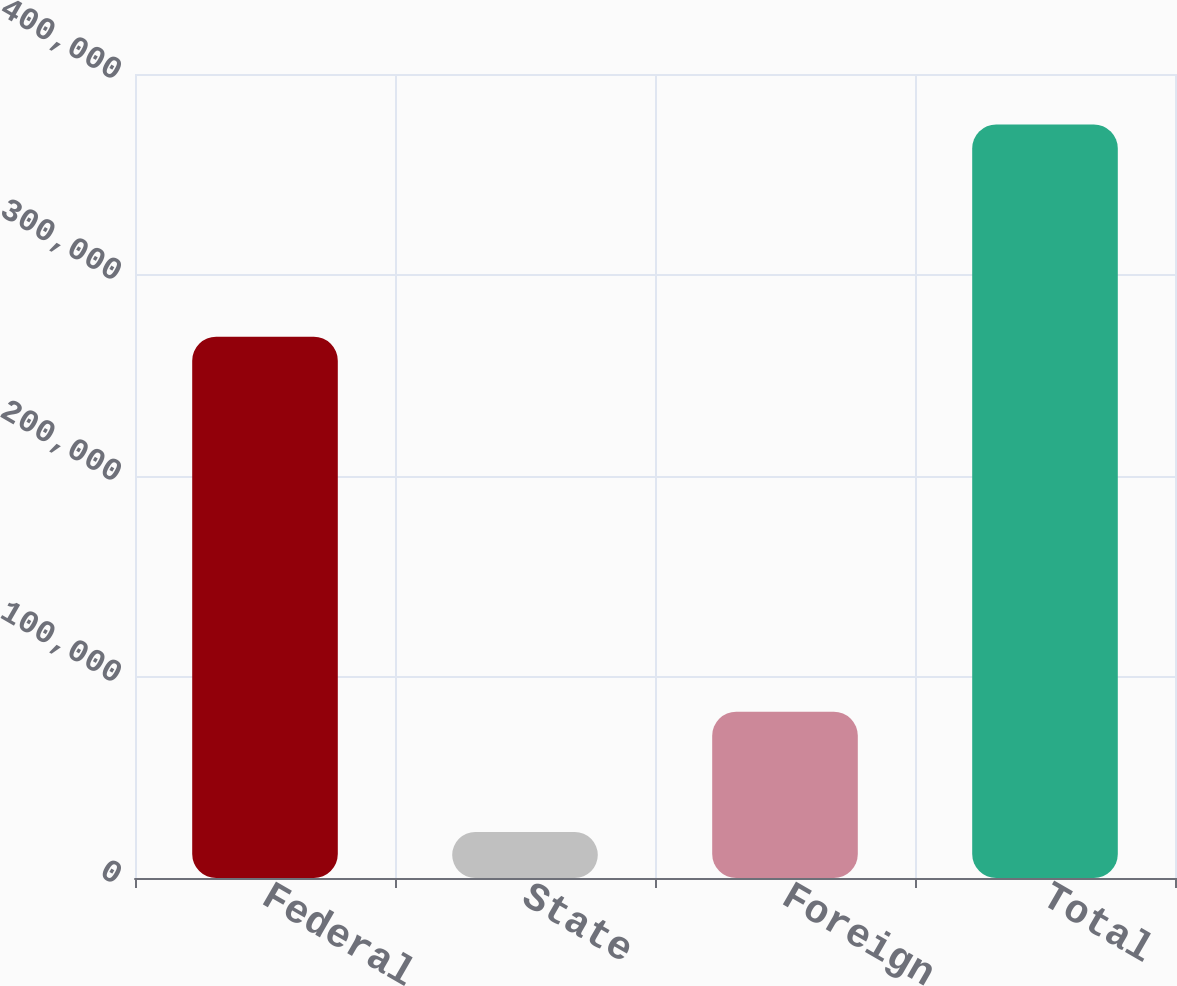Convert chart to OTSL. <chart><loc_0><loc_0><loc_500><loc_500><bar_chart><fcel>Federal<fcel>State<fcel>Foreign<fcel>Total<nl><fcel>269326<fcel>22835<fcel>82721<fcel>374882<nl></chart> 